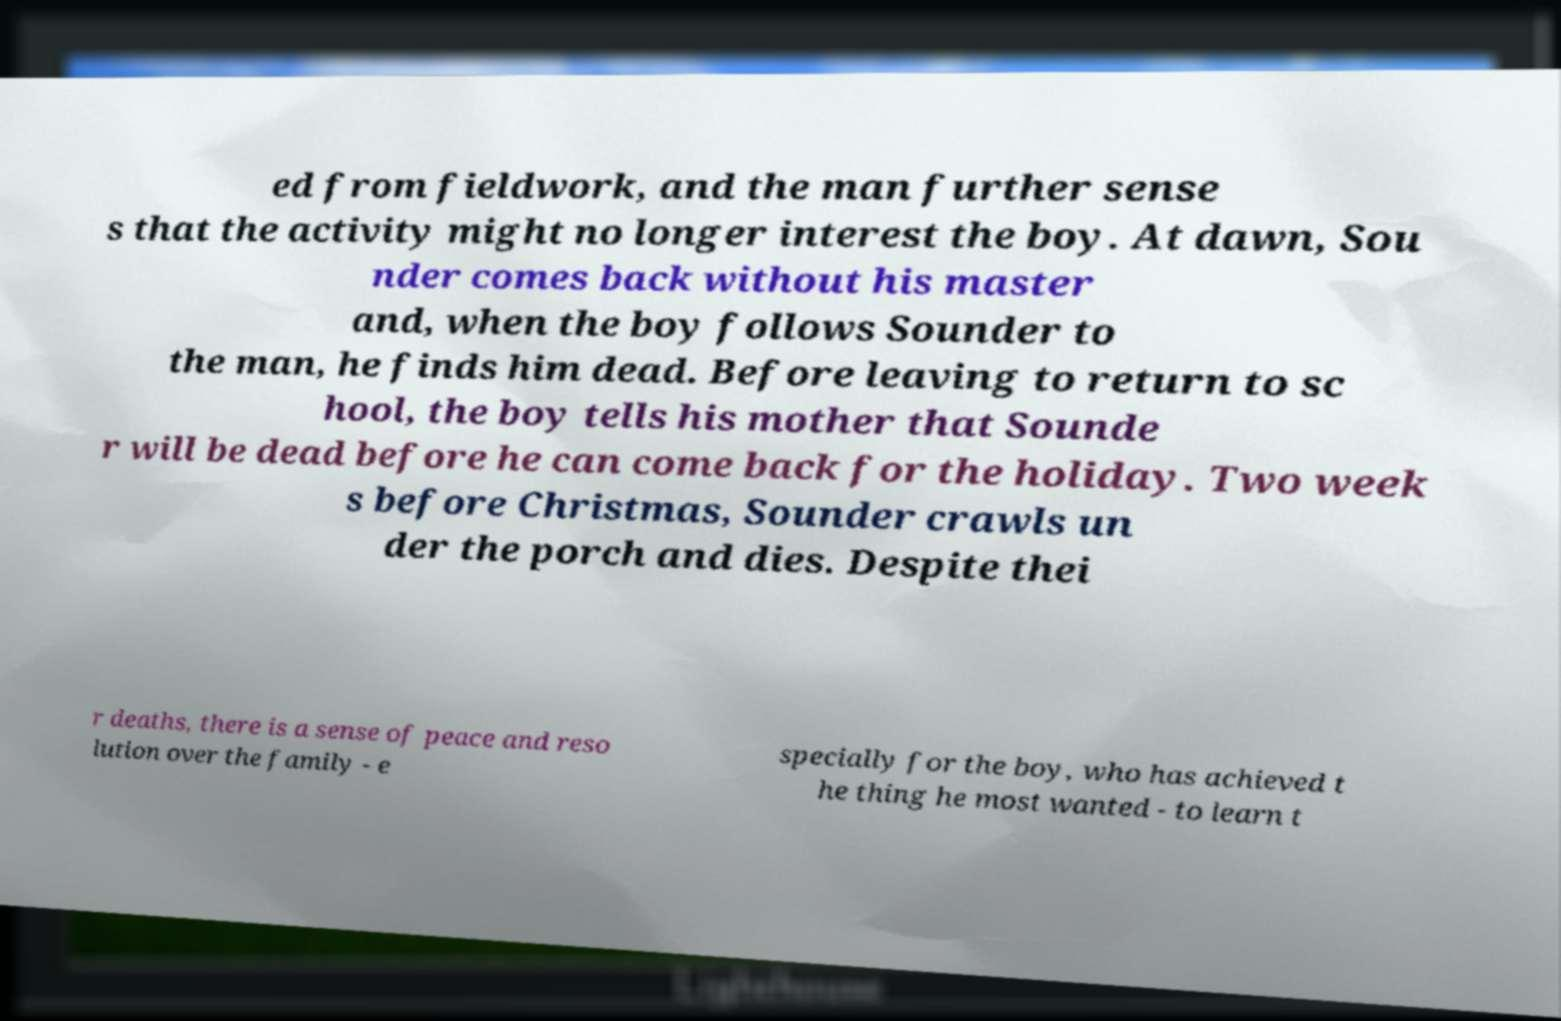There's text embedded in this image that I need extracted. Can you transcribe it verbatim? ed from fieldwork, and the man further sense s that the activity might no longer interest the boy. At dawn, Sou nder comes back without his master and, when the boy follows Sounder to the man, he finds him dead. Before leaving to return to sc hool, the boy tells his mother that Sounde r will be dead before he can come back for the holiday. Two week s before Christmas, Sounder crawls un der the porch and dies. Despite thei r deaths, there is a sense of peace and reso lution over the family - e specially for the boy, who has achieved t he thing he most wanted - to learn t 